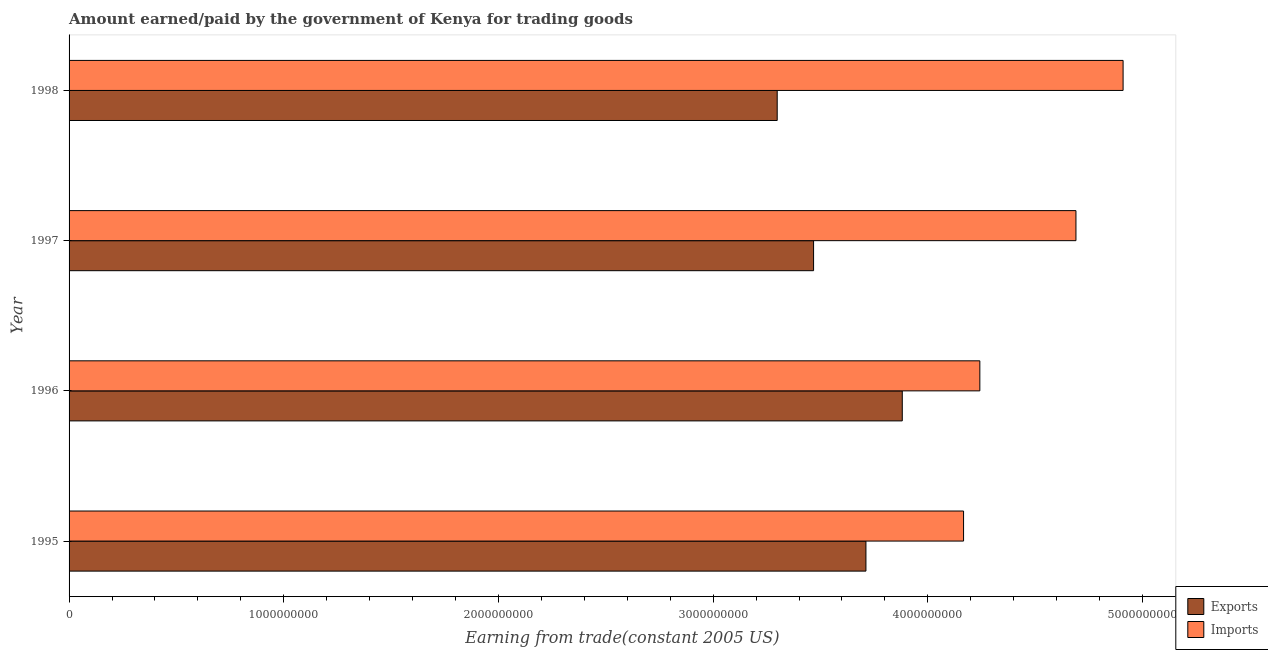How many groups of bars are there?
Offer a very short reply. 4. How many bars are there on the 1st tick from the top?
Your answer should be very brief. 2. What is the amount paid for imports in 1996?
Make the answer very short. 4.24e+09. Across all years, what is the maximum amount earned from exports?
Offer a very short reply. 3.88e+09. Across all years, what is the minimum amount paid for imports?
Make the answer very short. 4.17e+09. In which year was the amount paid for imports maximum?
Provide a succinct answer. 1998. In which year was the amount paid for imports minimum?
Your answer should be compact. 1995. What is the total amount paid for imports in the graph?
Your answer should be compact. 1.80e+1. What is the difference between the amount paid for imports in 1996 and that in 1997?
Give a very brief answer. -4.48e+08. What is the difference between the amount earned from exports in 1997 and the amount paid for imports in 1996?
Provide a short and direct response. -7.74e+08. What is the average amount earned from exports per year?
Provide a short and direct response. 3.59e+09. In the year 1995, what is the difference between the amount paid for imports and amount earned from exports?
Provide a succinct answer. 4.55e+08. What is the ratio of the amount paid for imports in 1995 to that in 1997?
Keep it short and to the point. 0.89. Is the amount earned from exports in 1995 less than that in 1997?
Provide a succinct answer. No. What is the difference between the highest and the second highest amount earned from exports?
Offer a terse response. 1.69e+08. What is the difference between the highest and the lowest amount earned from exports?
Make the answer very short. 5.83e+08. In how many years, is the amount earned from exports greater than the average amount earned from exports taken over all years?
Give a very brief answer. 2. What does the 1st bar from the top in 1997 represents?
Give a very brief answer. Imports. What does the 1st bar from the bottom in 1996 represents?
Make the answer very short. Exports. Are all the bars in the graph horizontal?
Your answer should be compact. Yes. Does the graph contain grids?
Provide a succinct answer. No. What is the title of the graph?
Keep it short and to the point. Amount earned/paid by the government of Kenya for trading goods. What is the label or title of the X-axis?
Your answer should be compact. Earning from trade(constant 2005 US). What is the Earning from trade(constant 2005 US) of Exports in 1995?
Offer a very short reply. 3.71e+09. What is the Earning from trade(constant 2005 US) in Imports in 1995?
Your response must be concise. 4.17e+09. What is the Earning from trade(constant 2005 US) of Exports in 1996?
Your answer should be compact. 3.88e+09. What is the Earning from trade(constant 2005 US) in Imports in 1996?
Your response must be concise. 4.24e+09. What is the Earning from trade(constant 2005 US) of Exports in 1997?
Provide a short and direct response. 3.47e+09. What is the Earning from trade(constant 2005 US) of Imports in 1997?
Provide a succinct answer. 4.69e+09. What is the Earning from trade(constant 2005 US) of Exports in 1998?
Offer a terse response. 3.30e+09. What is the Earning from trade(constant 2005 US) in Imports in 1998?
Offer a terse response. 4.91e+09. Across all years, what is the maximum Earning from trade(constant 2005 US) in Exports?
Your answer should be very brief. 3.88e+09. Across all years, what is the maximum Earning from trade(constant 2005 US) of Imports?
Your answer should be very brief. 4.91e+09. Across all years, what is the minimum Earning from trade(constant 2005 US) of Exports?
Provide a succinct answer. 3.30e+09. Across all years, what is the minimum Earning from trade(constant 2005 US) in Imports?
Give a very brief answer. 4.17e+09. What is the total Earning from trade(constant 2005 US) of Exports in the graph?
Make the answer very short. 1.44e+1. What is the total Earning from trade(constant 2005 US) in Imports in the graph?
Keep it short and to the point. 1.80e+1. What is the difference between the Earning from trade(constant 2005 US) of Exports in 1995 and that in 1996?
Provide a short and direct response. -1.69e+08. What is the difference between the Earning from trade(constant 2005 US) in Imports in 1995 and that in 1996?
Provide a succinct answer. -7.59e+07. What is the difference between the Earning from trade(constant 2005 US) in Exports in 1995 and that in 1997?
Offer a very short reply. 2.44e+08. What is the difference between the Earning from trade(constant 2005 US) in Imports in 1995 and that in 1997?
Offer a very short reply. -5.24e+08. What is the difference between the Earning from trade(constant 2005 US) of Exports in 1995 and that in 1998?
Provide a short and direct response. 4.13e+08. What is the difference between the Earning from trade(constant 2005 US) in Imports in 1995 and that in 1998?
Offer a terse response. -7.43e+08. What is the difference between the Earning from trade(constant 2005 US) in Exports in 1996 and that in 1997?
Provide a succinct answer. 4.13e+08. What is the difference between the Earning from trade(constant 2005 US) in Imports in 1996 and that in 1997?
Provide a succinct answer. -4.48e+08. What is the difference between the Earning from trade(constant 2005 US) of Exports in 1996 and that in 1998?
Give a very brief answer. 5.83e+08. What is the difference between the Earning from trade(constant 2005 US) of Imports in 1996 and that in 1998?
Ensure brevity in your answer.  -6.67e+08. What is the difference between the Earning from trade(constant 2005 US) of Exports in 1997 and that in 1998?
Offer a terse response. 1.69e+08. What is the difference between the Earning from trade(constant 2005 US) of Imports in 1997 and that in 1998?
Your answer should be compact. -2.20e+08. What is the difference between the Earning from trade(constant 2005 US) of Exports in 1995 and the Earning from trade(constant 2005 US) of Imports in 1996?
Provide a succinct answer. -5.31e+08. What is the difference between the Earning from trade(constant 2005 US) of Exports in 1995 and the Earning from trade(constant 2005 US) of Imports in 1997?
Your answer should be compact. -9.78e+08. What is the difference between the Earning from trade(constant 2005 US) in Exports in 1995 and the Earning from trade(constant 2005 US) in Imports in 1998?
Give a very brief answer. -1.20e+09. What is the difference between the Earning from trade(constant 2005 US) in Exports in 1996 and the Earning from trade(constant 2005 US) in Imports in 1997?
Give a very brief answer. -8.09e+08. What is the difference between the Earning from trade(constant 2005 US) in Exports in 1996 and the Earning from trade(constant 2005 US) in Imports in 1998?
Make the answer very short. -1.03e+09. What is the difference between the Earning from trade(constant 2005 US) of Exports in 1997 and the Earning from trade(constant 2005 US) of Imports in 1998?
Make the answer very short. -1.44e+09. What is the average Earning from trade(constant 2005 US) of Exports per year?
Provide a succinct answer. 3.59e+09. What is the average Earning from trade(constant 2005 US) of Imports per year?
Make the answer very short. 4.50e+09. In the year 1995, what is the difference between the Earning from trade(constant 2005 US) in Exports and Earning from trade(constant 2005 US) in Imports?
Your response must be concise. -4.55e+08. In the year 1996, what is the difference between the Earning from trade(constant 2005 US) of Exports and Earning from trade(constant 2005 US) of Imports?
Your answer should be very brief. -3.61e+08. In the year 1997, what is the difference between the Earning from trade(constant 2005 US) in Exports and Earning from trade(constant 2005 US) in Imports?
Your answer should be compact. -1.22e+09. In the year 1998, what is the difference between the Earning from trade(constant 2005 US) in Exports and Earning from trade(constant 2005 US) in Imports?
Provide a succinct answer. -1.61e+09. What is the ratio of the Earning from trade(constant 2005 US) of Exports in 1995 to that in 1996?
Offer a terse response. 0.96. What is the ratio of the Earning from trade(constant 2005 US) of Imports in 1995 to that in 1996?
Offer a terse response. 0.98. What is the ratio of the Earning from trade(constant 2005 US) of Exports in 1995 to that in 1997?
Your answer should be very brief. 1.07. What is the ratio of the Earning from trade(constant 2005 US) in Imports in 1995 to that in 1997?
Provide a short and direct response. 0.89. What is the ratio of the Earning from trade(constant 2005 US) of Exports in 1995 to that in 1998?
Keep it short and to the point. 1.13. What is the ratio of the Earning from trade(constant 2005 US) in Imports in 1995 to that in 1998?
Your answer should be very brief. 0.85. What is the ratio of the Earning from trade(constant 2005 US) in Exports in 1996 to that in 1997?
Ensure brevity in your answer.  1.12. What is the ratio of the Earning from trade(constant 2005 US) in Imports in 1996 to that in 1997?
Your response must be concise. 0.9. What is the ratio of the Earning from trade(constant 2005 US) of Exports in 1996 to that in 1998?
Provide a short and direct response. 1.18. What is the ratio of the Earning from trade(constant 2005 US) in Imports in 1996 to that in 1998?
Provide a succinct answer. 0.86. What is the ratio of the Earning from trade(constant 2005 US) in Exports in 1997 to that in 1998?
Offer a terse response. 1.05. What is the ratio of the Earning from trade(constant 2005 US) of Imports in 1997 to that in 1998?
Provide a succinct answer. 0.96. What is the difference between the highest and the second highest Earning from trade(constant 2005 US) of Exports?
Provide a succinct answer. 1.69e+08. What is the difference between the highest and the second highest Earning from trade(constant 2005 US) in Imports?
Give a very brief answer. 2.20e+08. What is the difference between the highest and the lowest Earning from trade(constant 2005 US) of Exports?
Ensure brevity in your answer.  5.83e+08. What is the difference between the highest and the lowest Earning from trade(constant 2005 US) of Imports?
Provide a succinct answer. 7.43e+08. 